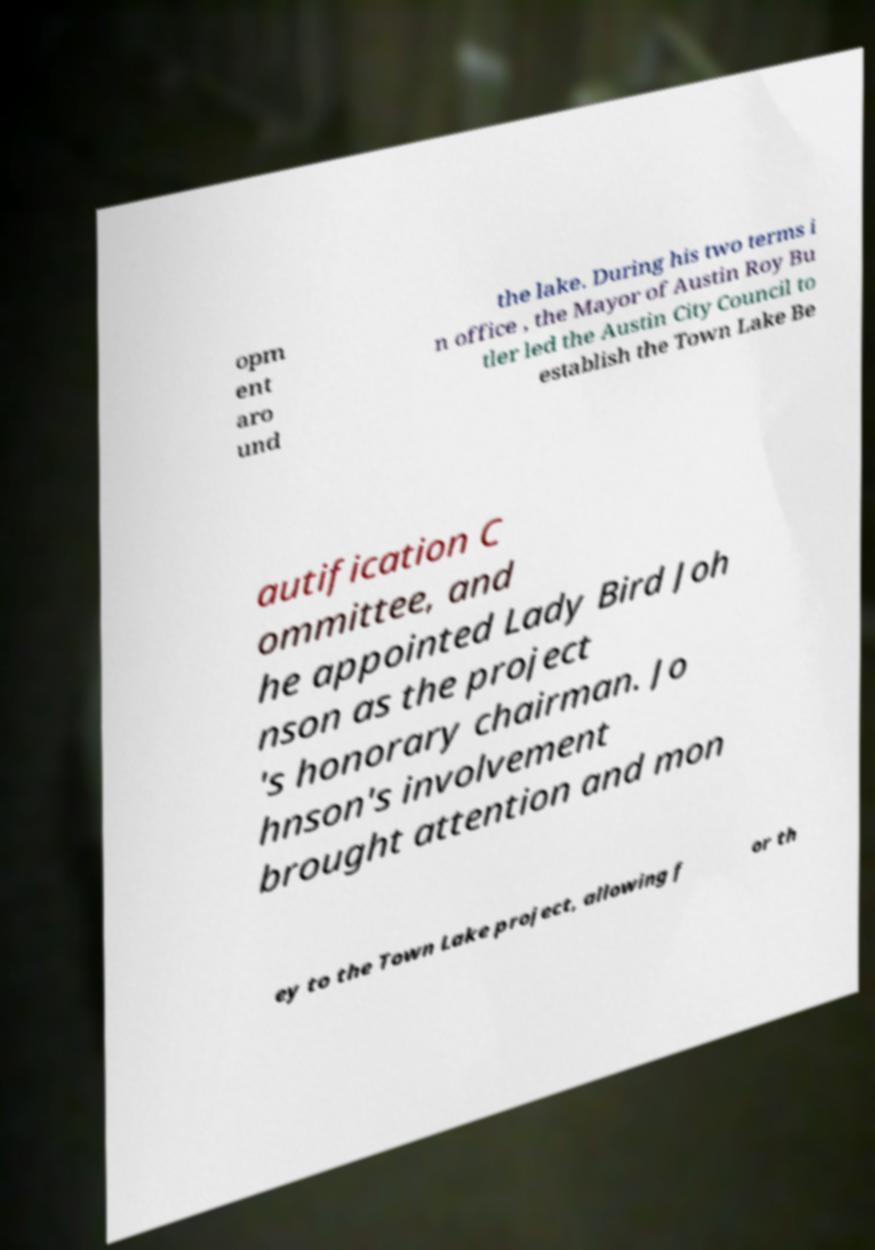Please identify and transcribe the text found in this image. opm ent aro und the lake. During his two terms i n office , the Mayor of Austin Roy Bu tler led the Austin City Council to establish the Town Lake Be autification C ommittee, and he appointed Lady Bird Joh nson as the project 's honorary chairman. Jo hnson's involvement brought attention and mon ey to the Town Lake project, allowing f or th 